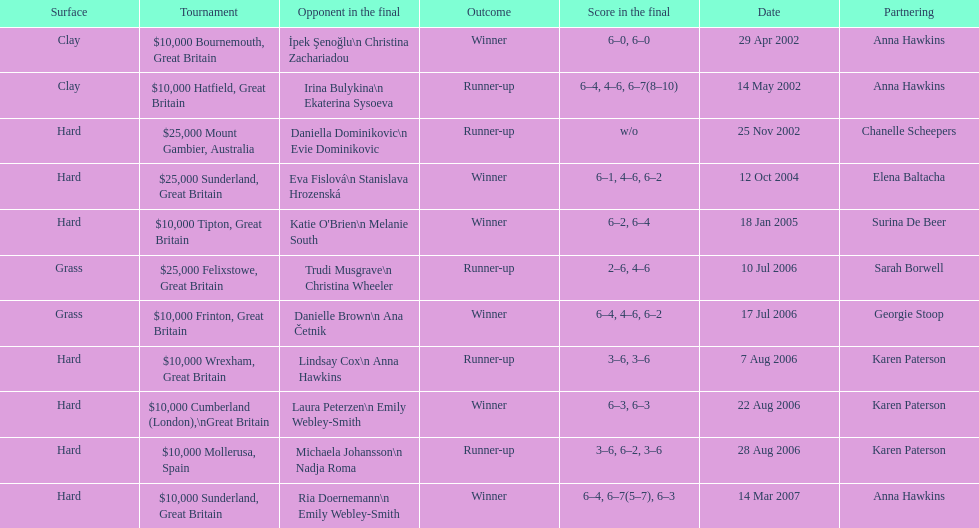How many were played on a hard surface? 7. 